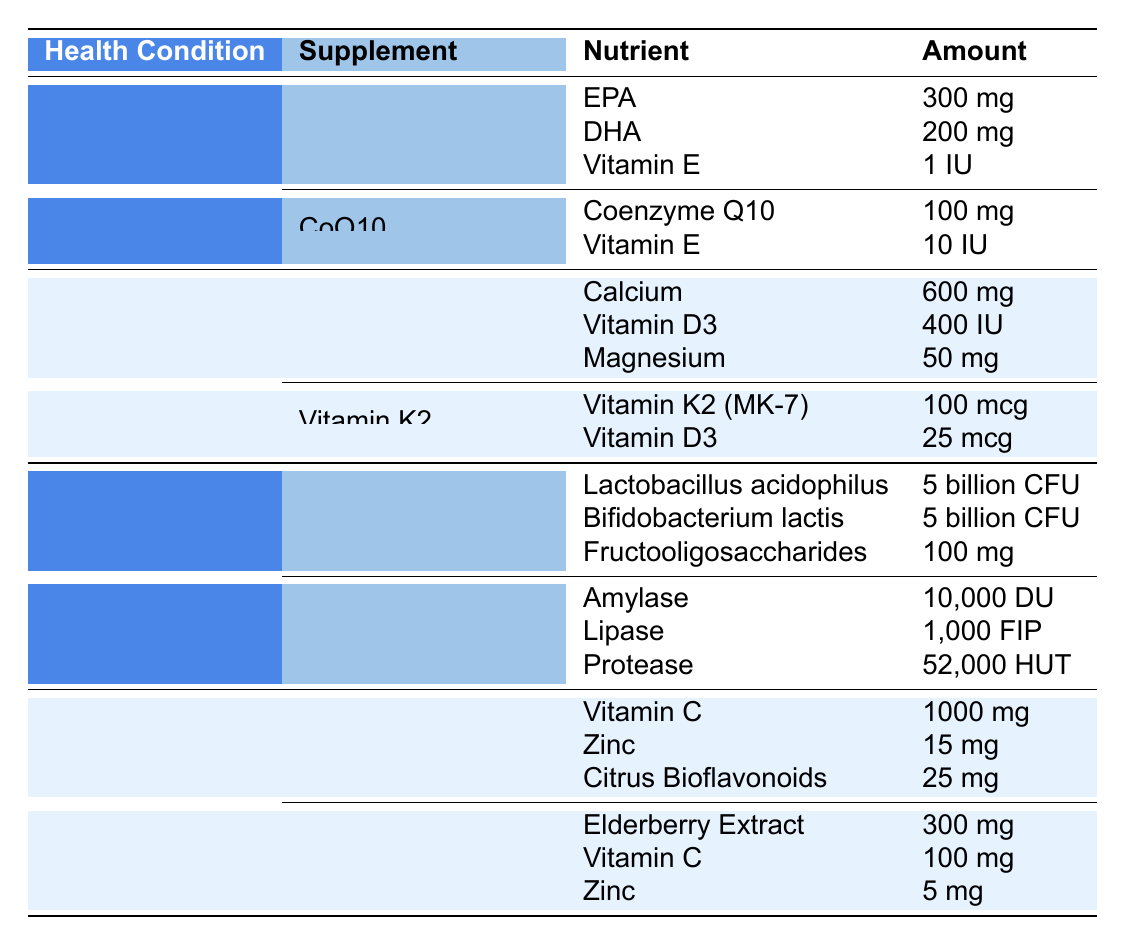What nutrients are found in Fish Oil? Fish Oil has three nutrients listed in the table: EPA, DHA, and Vitamin E. The amounts are 300 mg for EPA, 200 mg for DHA, and 1 IU for Vitamin E.
Answer: EPA, DHA, Vitamin E Which supplement lists the highest amount of Vitamin C? In the table, Vitamin C + Zinc has 1000 mg of Vitamin C, which is higher than the 100 mg of Vitamin C found in Elderberry.
Answer: Vitamin C + Zinc How many different nutrients are present in the Bone Health supplements? The Bone Health section has two supplements: Calcium + Vitamin D (with three nutrients) and Vitamin K2 (with two nutrients). Therefore, there are a total of 3 + 2 = 5 unique nutrients listed.
Answer: 5 Does Fish Oil contain Vitamin D? The table lists Fish Oil with three nutrients: EPA, DHA, and Vitamin E. There is no mention of Vitamin D in its nutrient list.
Answer: No What is the total amount of Zinc found in both immune support supplements? The supplements in the Immune Support section are Vitamin C + Zinc (15 mg of Zinc) and Elderberry (5 mg of Zinc). Adding these gives 15 mg + 5 mg = 20 mg total Zinc.
Answer: 20 mg Which supplement in the Digestive Health category provides the highest amount of Protease? The Digestive Enzymes supplement contains 52,000 HUT of Protease, which is the only entry for Protease in the Digestive Health category, so it provides the highest amount.
Answer: Digestive Enzymes How does the amount of Magnesium in Calcium + Vitamin D compare to the amount of DHA in Fish Oil? The Calcium + Vitamin D supplement provides 50 mg of Magnesium, while Fish Oil provides 200 mg of DHA. Since 200 mg is greater than 50 mg, the DHA amount is higher.
Answer: DHA is higher What is the combined amount of Vitamin E in Fish Oil and CoQ10? Fish Oil contains 1 IU and CoQ10 contains 10 IU of Vitamin E. Adding them together gives 1 IU + 10 IU = 11 IU total Vitamin E in both supplements.
Answer: 11 IU Which health condition has the most supplements listed? The table shows 2 supplements for Heart Health, 2 for Bone Health, 2 for Digestive Health, and 2 for Immune Support. All conditions are represented equally, with no condition having more supplements than the others.
Answer: Equal number 